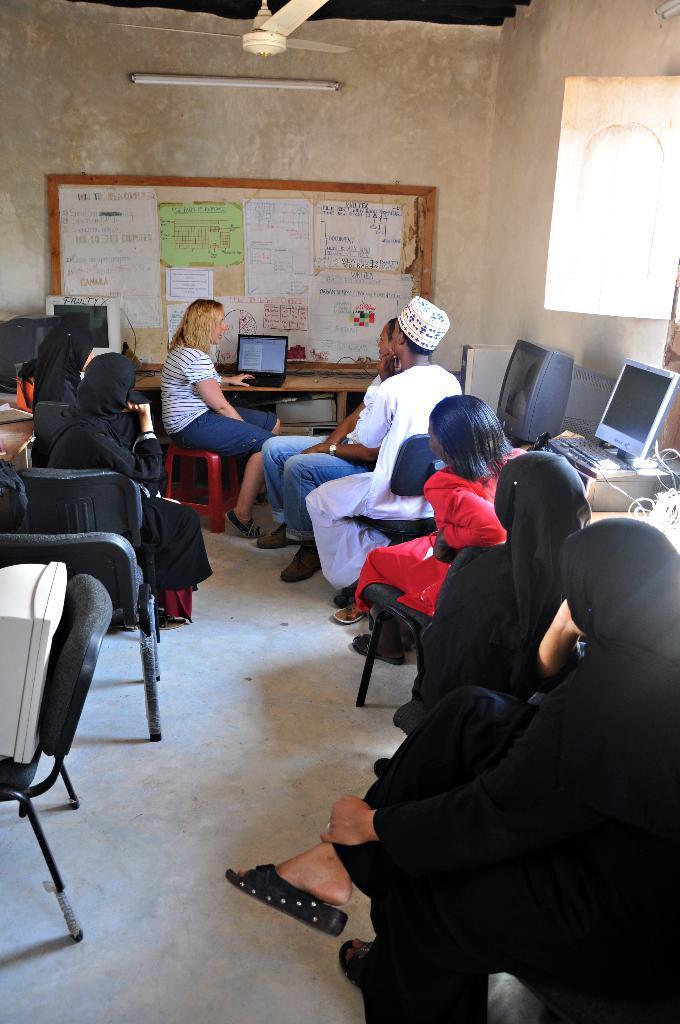How would you summarize this image in a sentence or two? There are many ladies sitting on a chairs. Beside them there are some monitors. There is a lady in the middle who is wearing a white t-shirt. In front of her there is a laptop. Behind her there is a board. On the board there are some papers. on the top corner there is a tube light. And we can also see a fan. 